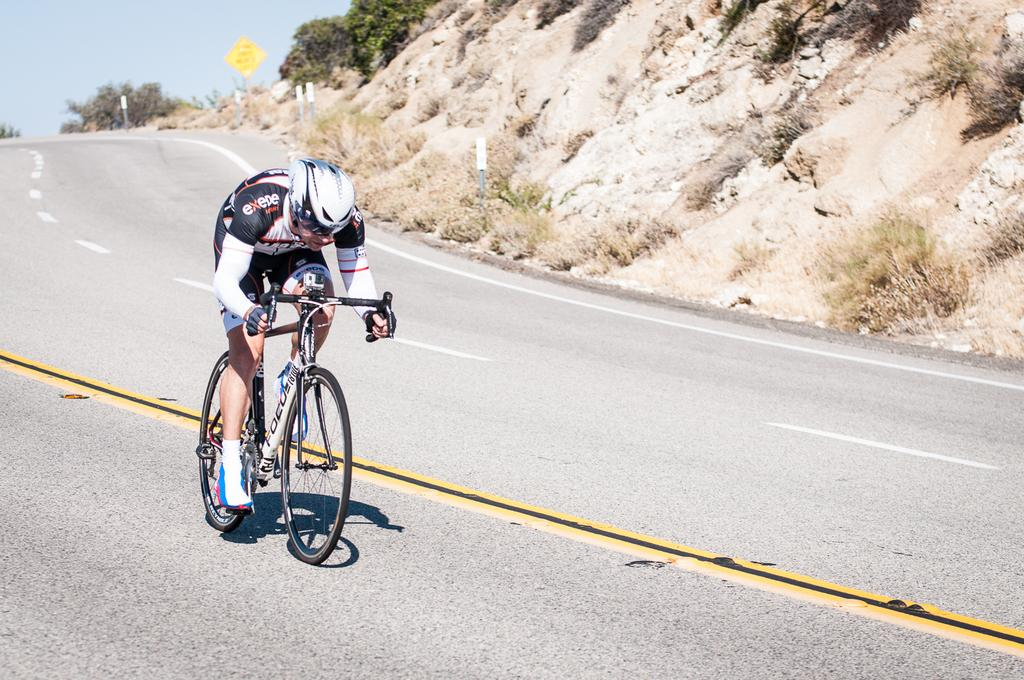What is the person in the image doing? There is a person riding a bicycle in the image. Where is the person riding the bicycle? The person is on the road. What can be seen in the background of the image? There are trees in the image. What else is present in the image besides the person and the trees? There is a board and the sky is visible in the image. What type of beef can be seen on the board in the image? There is no beef present in the image; the board is not mentioned as having any food items on it. 